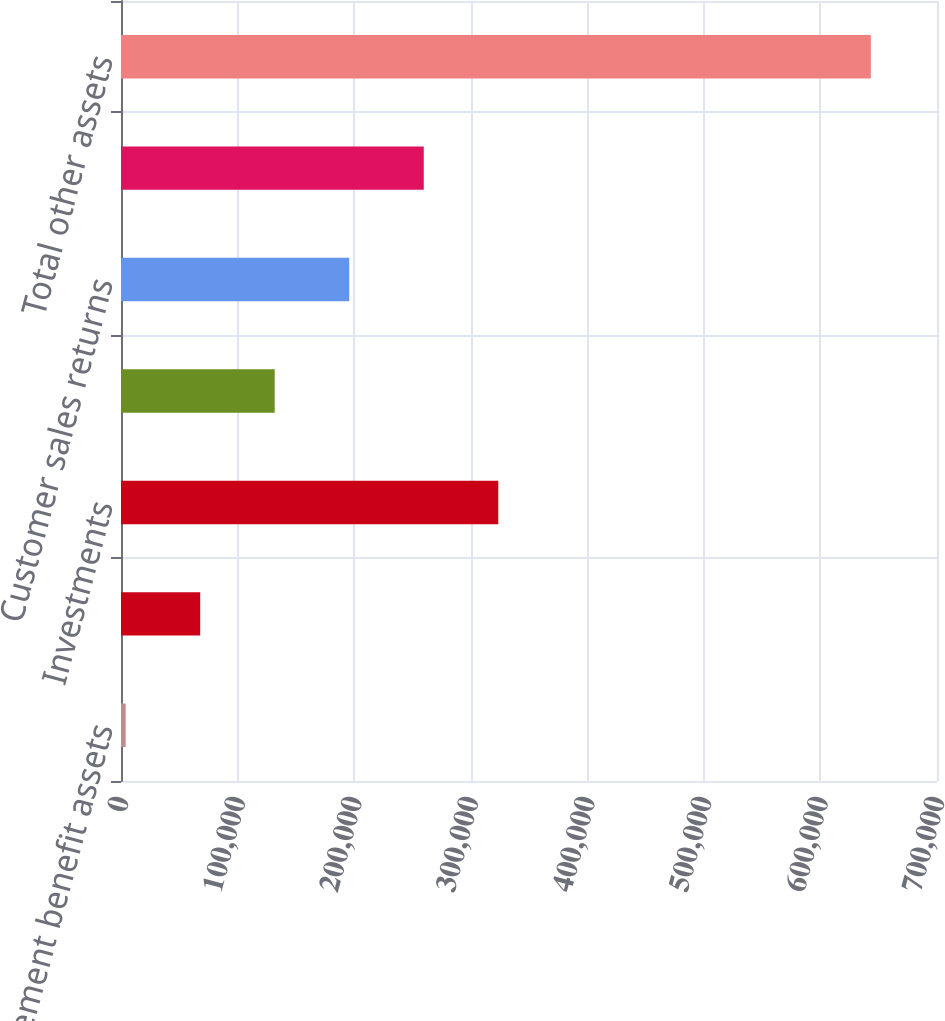<chart> <loc_0><loc_0><loc_500><loc_500><bar_chart><fcel>Retirement benefit assets<fcel>Deferred compensation benefits<fcel>Investments<fcel>Cash surrender value of life<fcel>Customer sales returns<fcel>Other long-term prepayments<fcel>Total other assets<nl><fcel>4021<fcel>67945.2<fcel>323642<fcel>131869<fcel>195794<fcel>259718<fcel>643263<nl></chart> 